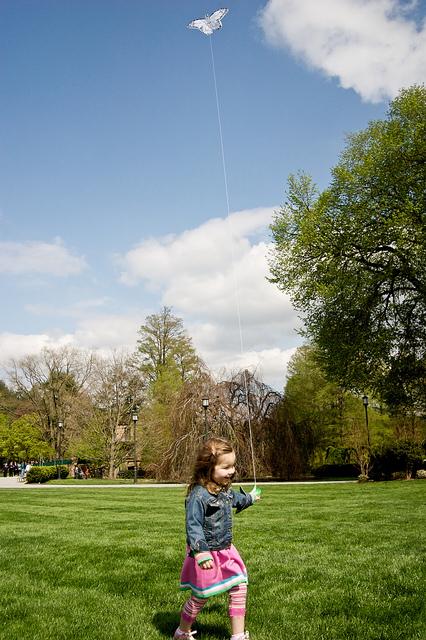What kind of jacket is the girl wearing?
Answer briefly. Denim. How many children are visible?
Give a very brief answer. 1. What is this little girl playing with?
Concise answer only. Kite. What color is the girl's skirt?
Give a very brief answer. Pink. 